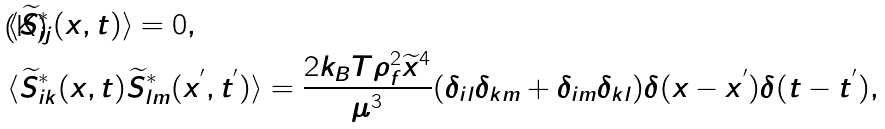Convert formula to latex. <formula><loc_0><loc_0><loc_500><loc_500>& \langle \widetilde { S } _ { i j } ^ { * } ( x , t ) \rangle = 0 , \\ & \langle \widetilde { S } _ { i k } ^ { * } ( x , t ) \widetilde { S } _ { l m } ^ { * } ( x ^ { ^ { \prime } } , t ^ { ^ { \prime } } ) \rangle = \frac { 2 k _ { B } T \rho _ { f } ^ { 2 } \widetilde { x } ^ { 4 } } { \mu ^ { 3 } } ( \delta _ { i l } \delta _ { k m } + \delta _ { i m } \delta _ { k l } ) \delta ( x - x ^ { ^ { \prime } } ) \delta ( t - t ^ { ^ { \prime } } ) ,</formula> 